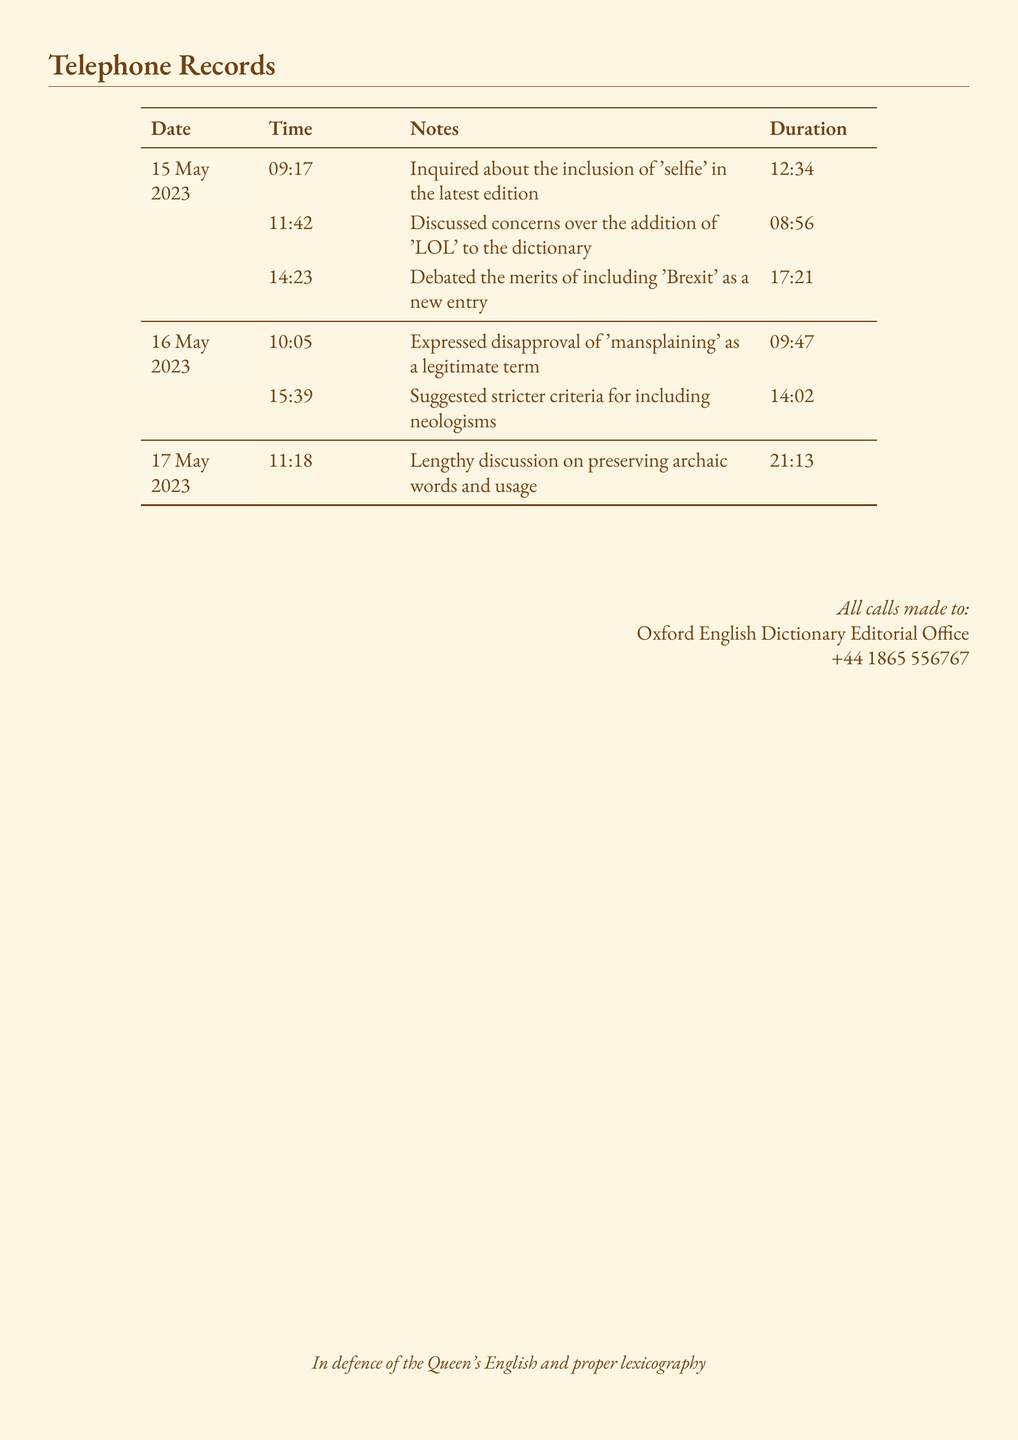What is the date of the first call? The first call is recorded on 15 May 2023.
Answer: 15 May 2023 How long was the longest call? The longest call lasted 21 minutes and 13 seconds as per the records.
Answer: 21:13 What was discussed in the call at 14:23? The call at 14:23 discussed the merits of including 'Brexit' as a new entry.
Answer: Debated the merits of including 'Brexit' as a new entry What time was the call about 'mansplaining'? The call about 'mansplaining' took place at 10:05.
Answer: 10:05 How many calls were made on 16 May 2023? There were two calls recorded on 16 May 2023.
Answer: 2 What is the total duration of calls made on 15 May 2023? The total duration is the sum of all call durations on that date, which is 12:34 + 08:56 + 17:21.
Answer: 38:51 At what time was the last recorded call? The last recorded call was made at 11:18.
Answer: 11:18 What concern was discussed during the call at 11:42? The call at 11:42 discussed concerns over the addition of 'LOL' to the dictionary.
Answer: Discussed concerns over the addition of 'LOL' What is the purpose of these calls? The calls were made for inquiries and discussions regarding language and dictionary entries.
Answer: Inquiries and discussions regarding language and dictionary entries 